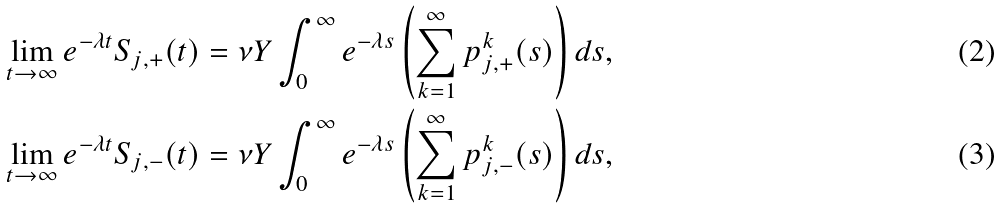<formula> <loc_0><loc_0><loc_500><loc_500>& \lim _ { t \to \infty } e ^ { - \lambda t } S _ { j , + } ( t ) = \nu Y \int _ { 0 } ^ { \infty } e ^ { - \lambda s } \left ( \sum _ { k = 1 } ^ { \infty } p _ { j , + } ^ { k } ( s ) \right ) d s , \\ & \lim _ { t \to \infty } e ^ { - \lambda t } S _ { j , - } ( t ) = \nu Y \int _ { 0 } ^ { \infty } e ^ { - \lambda s } \left ( \sum _ { k = 1 } ^ { \infty } p _ { j , - } ^ { k } ( s ) \right ) d s ,</formula> 